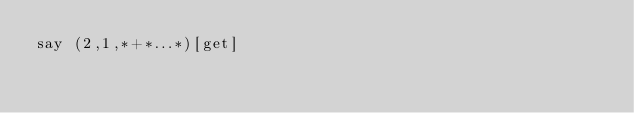<code> <loc_0><loc_0><loc_500><loc_500><_Perl_>say (2,1,*+*...*)[get]</code> 